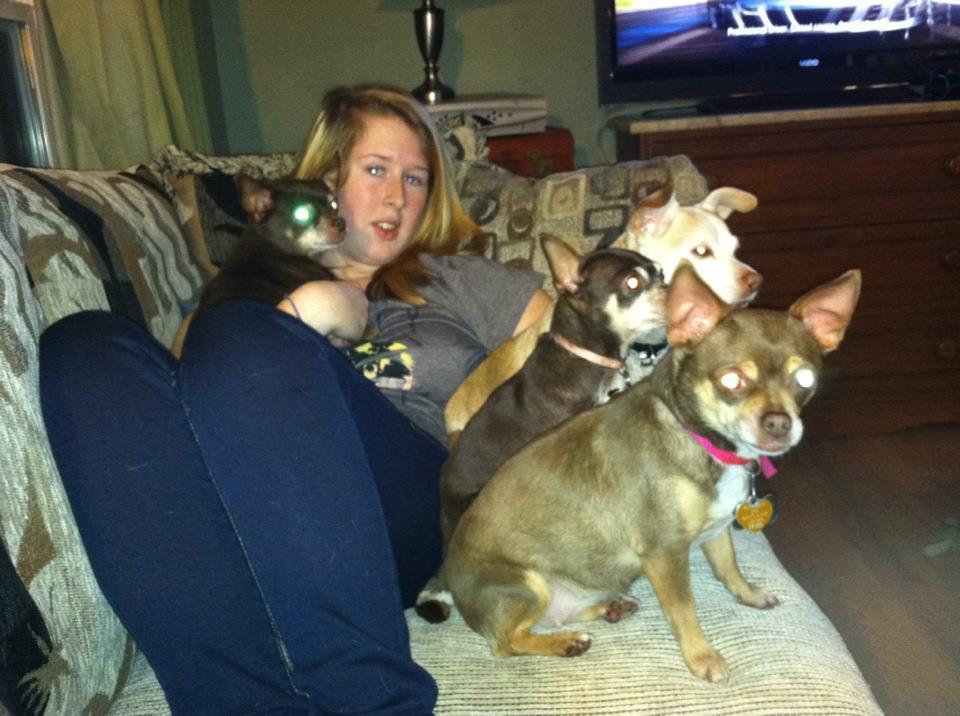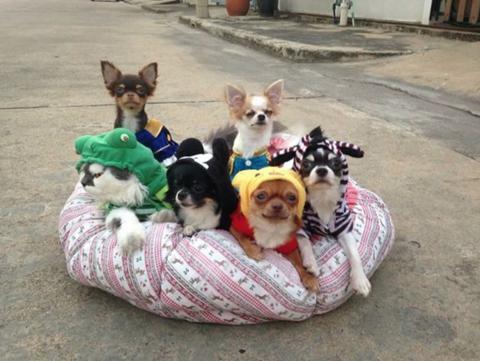The first image is the image on the left, the second image is the image on the right. For the images displayed, is the sentence "Each image shows a row of dressed dogs posing with a cat that is also wearing some garment." factually correct? Answer yes or no. No. The first image is the image on the left, the second image is the image on the right. For the images displayed, is the sentence "In at least one of the images, six dogs are posing for a picture, while on a bench." factually correct? Answer yes or no. No. 